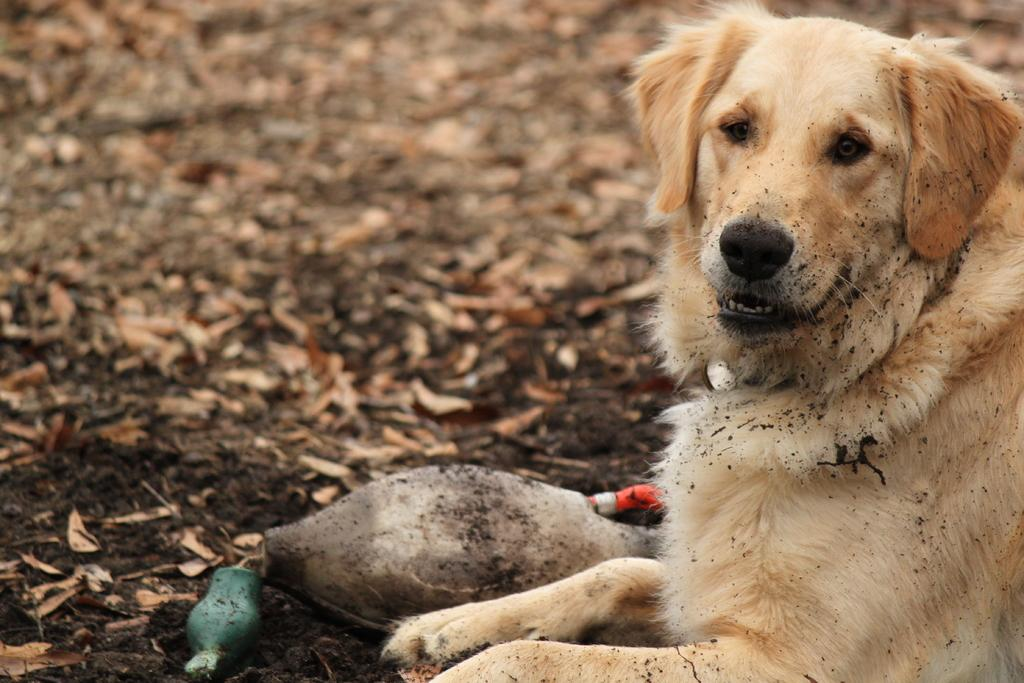What type of animal can be seen in the image? There is a dog in the image. What is located on the ground in the image? There is an object on the ground in the image. What type of natural debris is present in the image? Dried leaves are present in the image. Can you describe the beggar sitting on the street in the image? There is no beggar or street present in the image; it features a dog and an object on the ground. What type of goose is visible in the image? There is no goose present in the image; it features a dog and an object on the ground. 